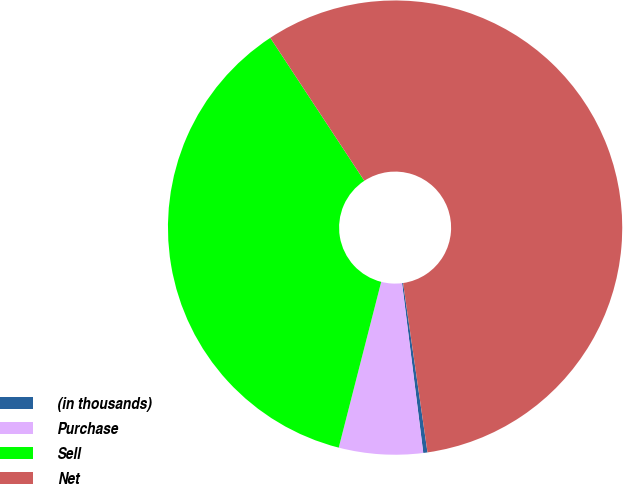Convert chart to OTSL. <chart><loc_0><loc_0><loc_500><loc_500><pie_chart><fcel>(in thousands)<fcel>Purchase<fcel>Sell<fcel>Net<nl><fcel>0.3%<fcel>5.97%<fcel>36.75%<fcel>56.98%<nl></chart> 